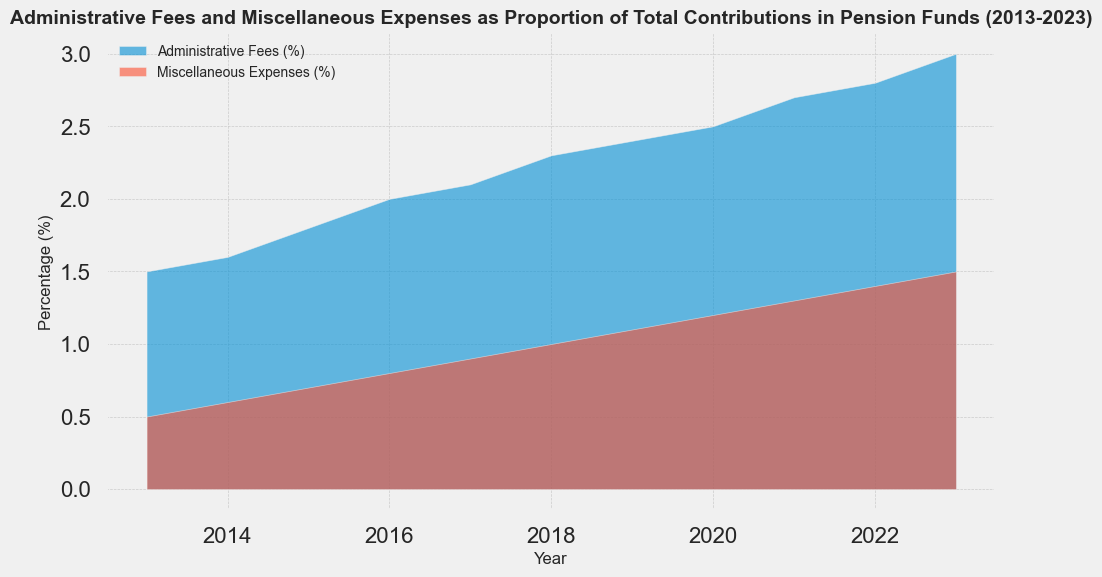What is the trend of Administrative Fees from 2013 to 2023? The Administrative Fees show a steady increase over the years. Starting at 1.5% in 2013, they gradually rise almost every year, reaching 3.0% in 2023. This indicates consistent growth in fees.
Answer: Steady increase In which year did Miscellaneous Expenses first exceed 1% of total contributions? According to the chart, Miscellaneous Expenses first exceed 1% in 2018, as the percentage reaches 1.0% exactly, and it's higher in subsequent years.
Answer: 2018 How much did Administrative Fees increase from 2013 to 2023? The Administrative Fees increased from 1.5% in 2013 to 3.0% in 2023. The difference is calculated as 3.0% - 1.5% = 1.5%.
Answer: 1.5% When comparing 2017 and 2023, which type of expense has grown more in percentage terms? In 2017, Administrative Fees were 2.1% and increased to 3.0% in 2023, a rise of 0.9%. Miscellaneous Expenses were 0.9% in 2017 and grew to 1.5% in 2023, a difference of 0.6%. Therefore, Administrative Fees grew more in percentage terms.
Answer: Administrative Fees What is the average percentage of Administrative Fees over the decade? Administrative Fees over the decade can be averaged as follows: (1.5 + 1.6 + 1.8 + 2.0 + 2.1 + 2.3 + 2.4 + 2.5 + 2.7 + 2.8 + 3.0) / 11 = 24.7 / 11 ≈ 2.25%.
Answer: 2.25% Was there any year Administrative Fees did not increase compared to the previous year? Observing the data visually, Administrative Fees increased every year from 2013 to 2023 without any year of decline or stagnation.
Answer: No How do the total percentages of Administrative Fees compare to Miscellaneous Expenses in 2023? In 2023, Administrative Fees are 3.0%, and Miscellaneous Expenses are 1.5%. The Administrative Fees are exactly double the Miscellaneous Expenses in that year.
Answer: Double By how much did combined expenses (Administrative Fees + Miscellaneous Expenses) increase from 2013 to 2023? In 2013, the combined expenses were 1.5% + 0.5% = 2.0%. In 2023, they were 3.0% + 1.5% = 4.5%. The increase over the decade is 4.5% - 2.0% = 2.5%.
Answer: 2.5% In what year was the difference between Administrative Fees and Miscellaneous Expenses the smallest? The smallest difference between Administrative Fees and Miscellaneous Expenses occurs in 2013, where the difference is 1.5% - 0.5% = 1.0%. This difference increases in subsequent years.
Answer: 2013 What is the visual trend for both Administrative Fees and Miscellaneous Expenses when comparing the first and last three years? Visually, in the first three years (2013-2015), both Administrative Fees and Miscellaneous Expenses are relatively low and increase gradually. In the last three years (2021-2023), both expenses are noticeably higher and show a steeper increase, illustrating accelerated growth.
Answer: Accelerated growth 